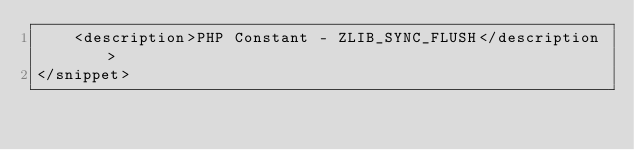<code> <loc_0><loc_0><loc_500><loc_500><_XML_>	<description>PHP Constant - ZLIB_SYNC_FLUSH</description>
</snippet></code> 